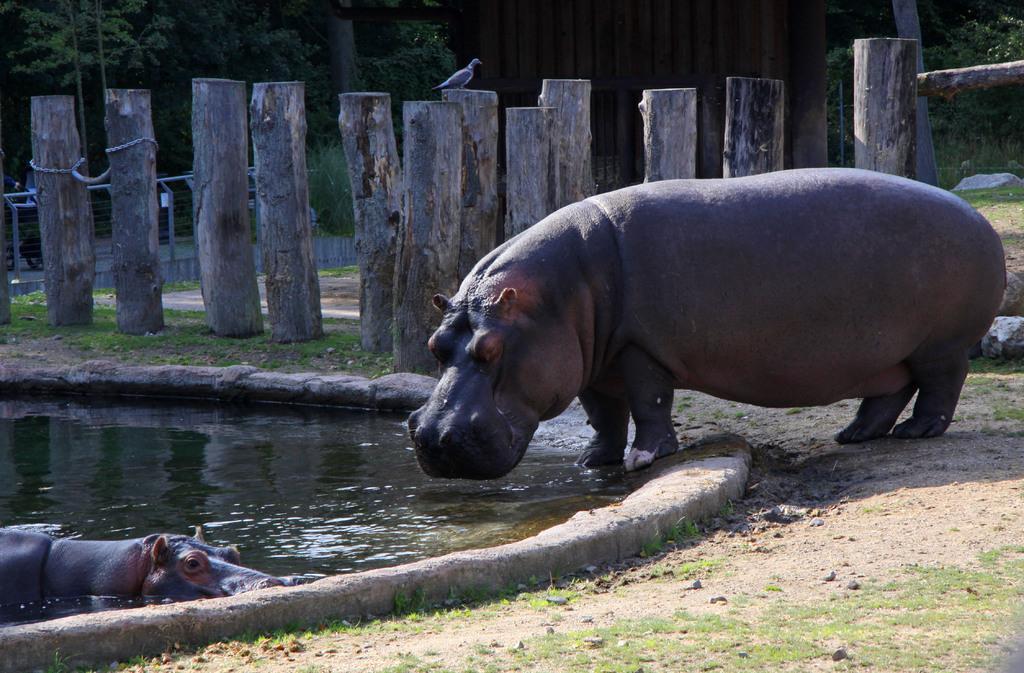Please provide a concise description of this image. In this image there is a hippopotamus standing on the ground and trying to drink the water. In the background there are wooden sticks. On the left side bottom there is another hippopotamus which is swimming in the water. In the background there is a wooden door, Beside the door there are trees. On the ground there are stones and grass. 